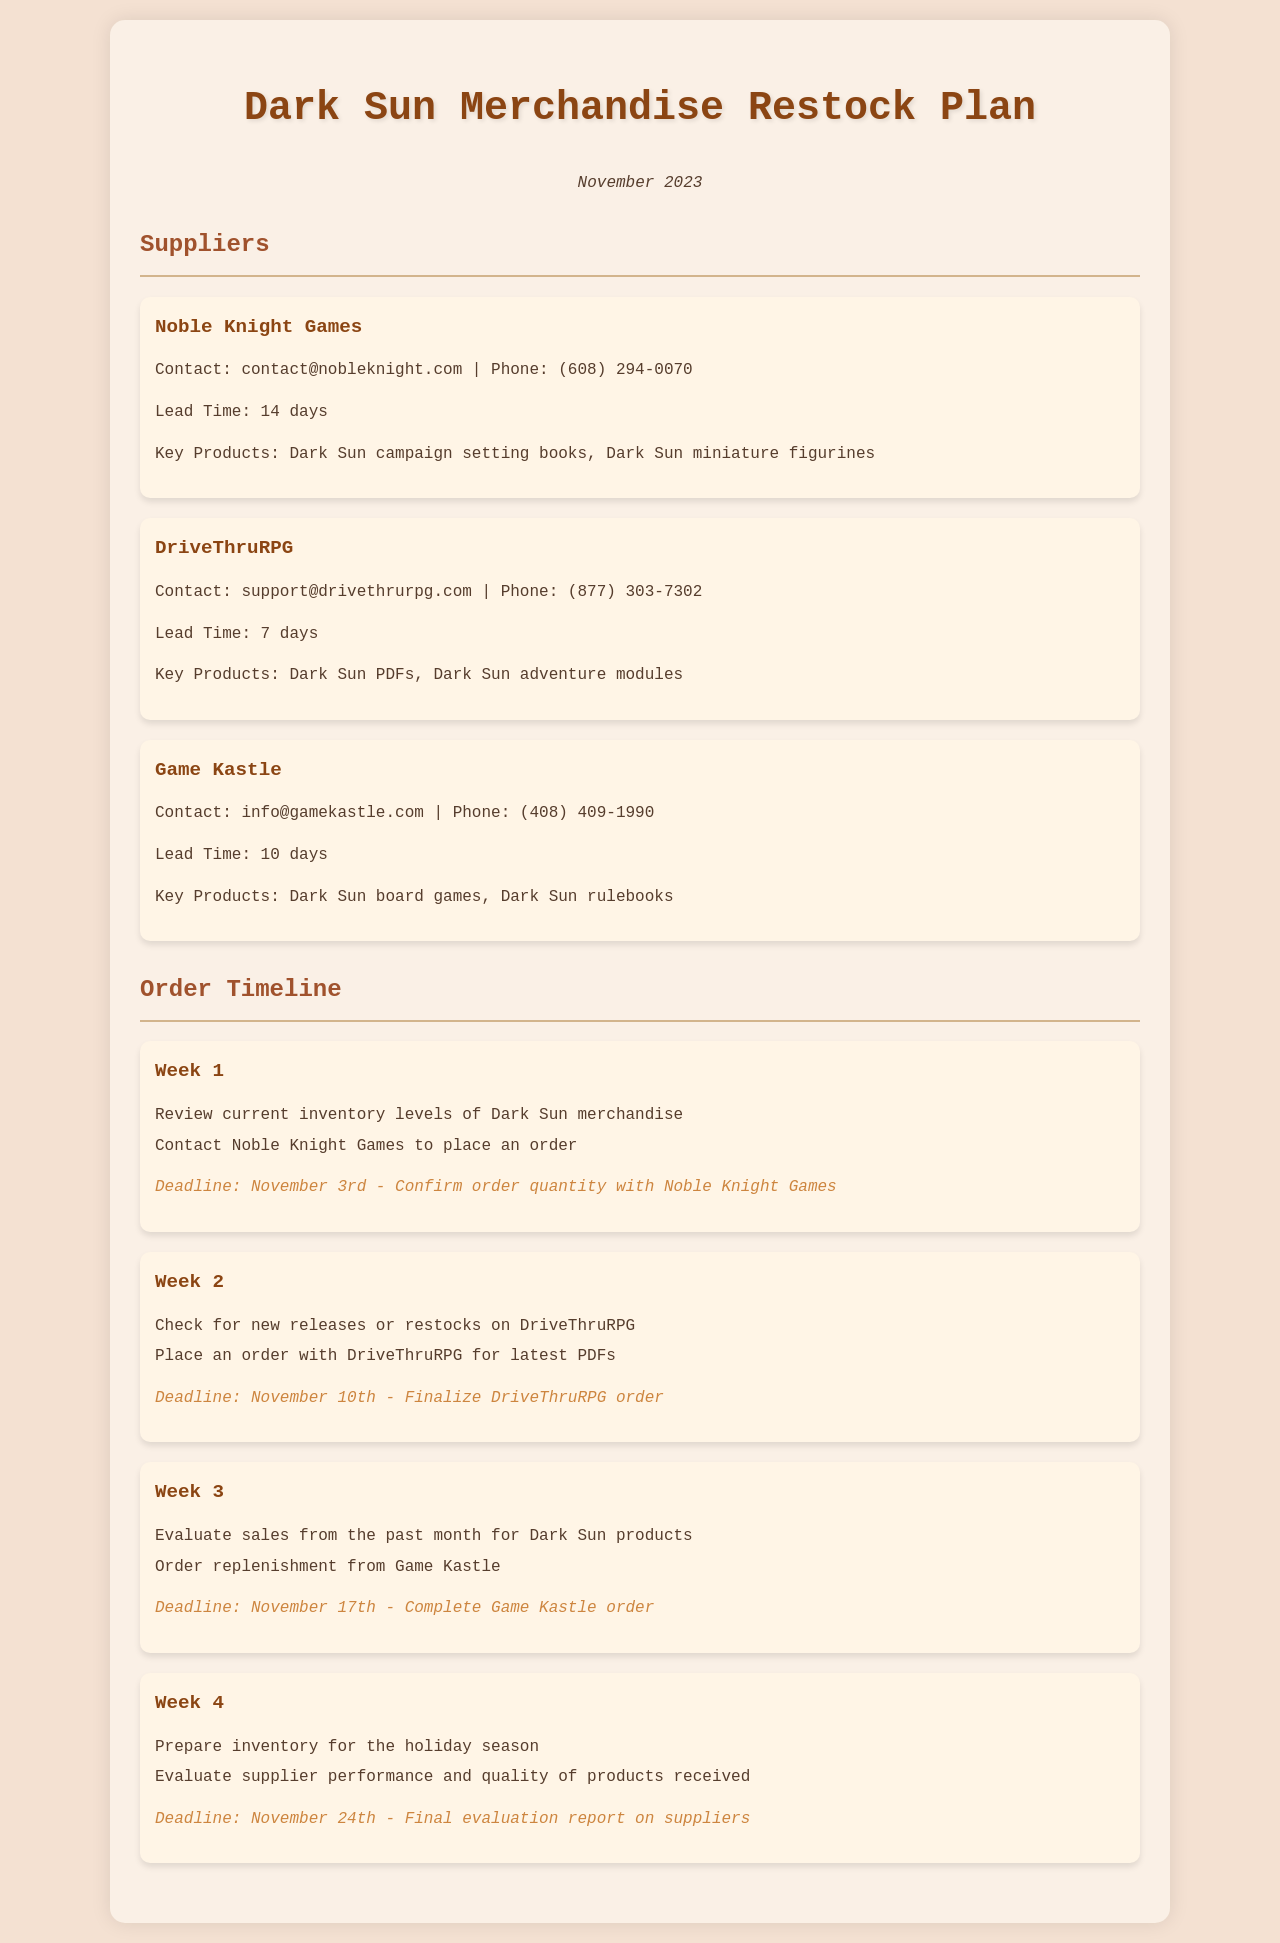what is the lead time for Noble Knight Games? The lead time for Noble Knight Games is stated in the document as 14 days.
Answer: 14 days which week involves ordering from DriveThruRPG? The document lists activities for each week, and Week 2 specifies placing an order with DriveThruRPG.
Answer: Week 2 what are the key products listed for Game Kastle? The document provides information about key products for each supplier, and for Game Kastle, they are Dark Sun board games and Dark Sun rulebooks.
Answer: Dark Sun board games, Dark Sun rulebooks when is the deadline to confirm order quantity with Noble Knight Games? The document specifies deadlines for actions, and the deadline for confirming order quantity with Noble Knight Games is November 3rd.
Answer: November 3rd which supplier's contact email is support@drivethrurpg.com? The document lists contacts for each supplier, and the email support@drivethrurpg.com belongs to DriveThruRPG.
Answer: DriveThruRPG what action is suggested for Week 4? The document outlines actions for each week, with Week 4 suggesting to prepare inventory for the holiday season and evaluate supplier performance.
Answer: Prepare inventory for the holiday season who should be contacted for a Game Kastle order? The document lists supplier contacts, and for Game Kastle, the contact email is info@gamekastle.com.
Answer: info@gamekastle.com what is the final evaluation report deadline on suppliers? The document specifies deadlines, and the final evaluation report deadline on suppliers is November 24th.
Answer: November 24th 